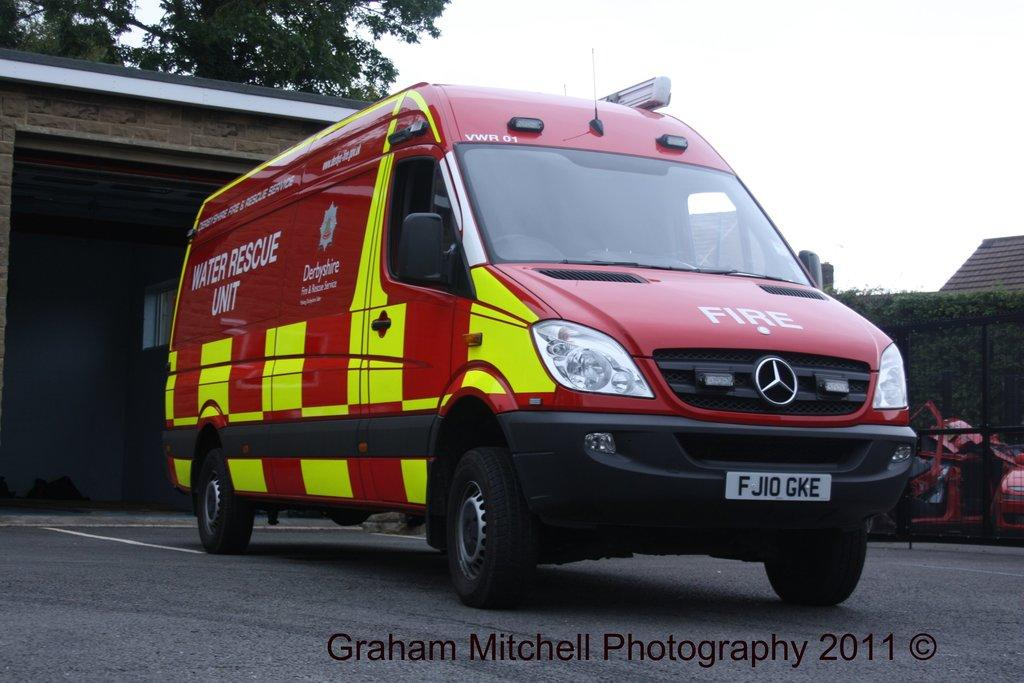<image>
Render a clear and concise summary of the photo. The red and yellow van belongs to the Derbyshire water rescue unit. 